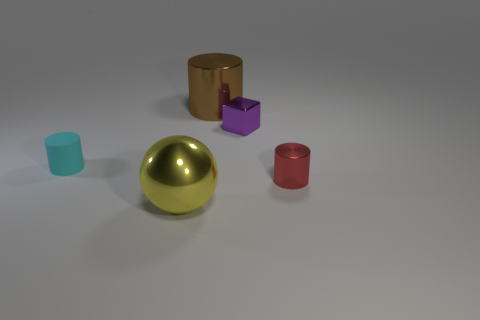Subtract all metallic cylinders. How many cylinders are left? 1 Add 3 small rubber cylinders. How many objects exist? 8 Subtract all brown cylinders. How many cylinders are left? 2 Add 1 small red metal cylinders. How many small red metal cylinders are left? 2 Add 3 big green matte things. How many big green matte things exist? 3 Subtract 0 yellow blocks. How many objects are left? 5 Subtract all blocks. How many objects are left? 4 Subtract all purple cylinders. Subtract all gray cubes. How many cylinders are left? 3 Subtract all red blocks. How many brown spheres are left? 0 Subtract all large brown spheres. Subtract all brown metal cylinders. How many objects are left? 4 